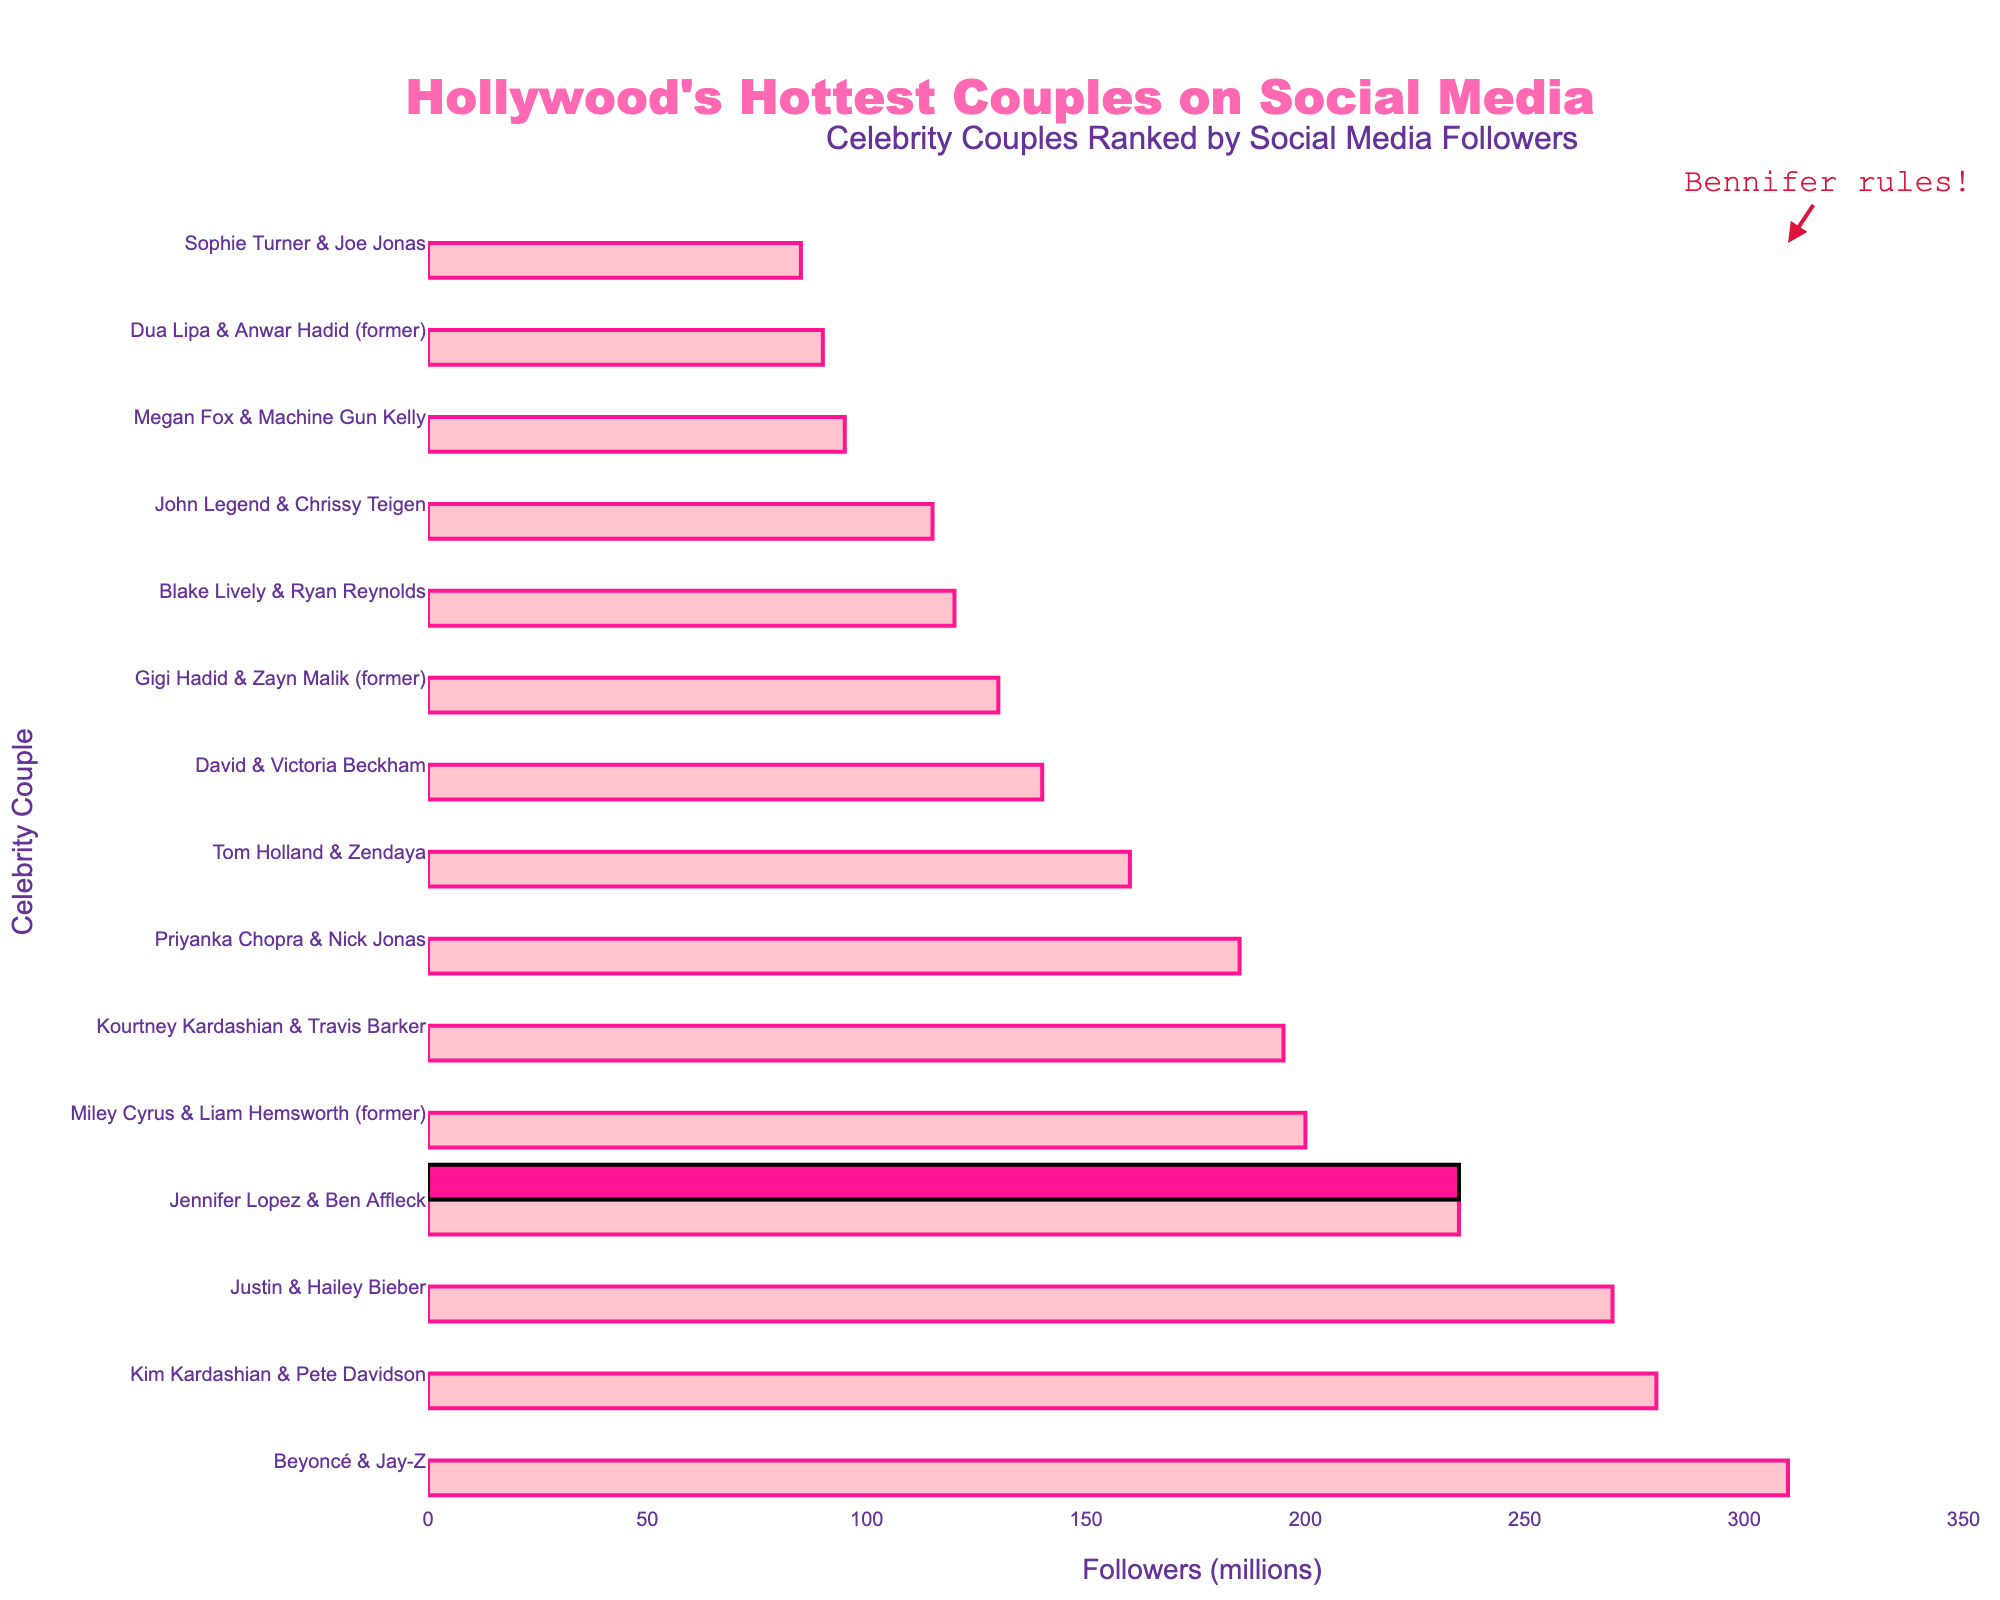Which celebrity couple has the most followers on social media? The bar chart shows the couple names and their follower counts. The highest bar and follower count belong to Beyoncé & Jay-Z.
Answer: Beyoncé & Jay-Z Do Jennifer Lopez & Ben Affleck have more followers than Blake Lively & Ryan Reynolds? Compare the lengths of the bars for both couples. Jennifer Lopez & Ben Affleck's bar is longer, indicating more followers than Blake Lively & Ryan Reynolds.
Answer: Yes How many more followers do Kim Kardashian & Pete Davidson have compared to Justin & Hailey Bieber? Subtract the follower count of Justin & Hailey Bieber from Kim Kardashian & Pete Davidson: 280 - 270 = 10.
Answer: 10 million What is the total follower count for the three former celebrity couples? Add the follower counts for Miley Cyrus & Liam Hemsworth (200), Gigi Hadid & Zayn Malik (130), and Dua Lipa & Anwar Hadid (90): 200 + 130 + 90 = 420.
Answer: 420 million Who has fewer followers, Megan Fox & Machine Gun Kelly, or Sophie Turner & Joe Jonas? Compare the lengths of the bars for both couples. Sophie Turner & Joe Jonas’ bar is shorter, indicating fewer followers than Megan Fox & Machine Gun Kelly.
Answer: Sophie Turner & Joe Jonas Which celebrity couple highlighted in pink has how many followers? The highlighted bar in bright pink is for Jennifer Lopez & Ben Affleck. The corresponding follower count from the chart is 235 million.
Answer: Jennifer Lopez & Ben Affleck, 235 million If you combine the follower counts of Tom Holland & Zendaya and John Legend & Chrissy Teigen, is it more than Priyanka Chopra & Nick Jonas? Add the follower counts: 160 (Tom & Zendaya) + 115 (John & Chrissy) = 275. 275 is greater than 185 (Priyanka & Nick).
Answer: Yes Are there more couples with over 200 million followers, or fewer than 200 million? Count the number of bars greater than 200 million and fewer than 200 million. There are four couples with over 200 million followers and ten with fewer than 200 million.
Answer: Fewer than 200 million What is the average follower count of the top five couples? Sum the follower counts of the top five couples and divide by 5: (310 + 280 + 270 + 235 + 200) / 5 = 1295 / 5 = 259.
Answer: 259 million 